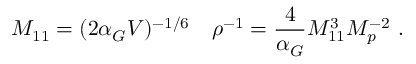Convert formula to latex. <formula><loc_0><loc_0><loc_500><loc_500>M _ { 1 1 } = ( 2 \alpha _ { G } V ) ^ { - 1 / 6 } \quad \rho ^ { - 1 } = { \frac { 4 } { \alpha _ { G } } } M _ { 1 1 } ^ { 3 } M _ { p } ^ { - 2 } \ .</formula> 